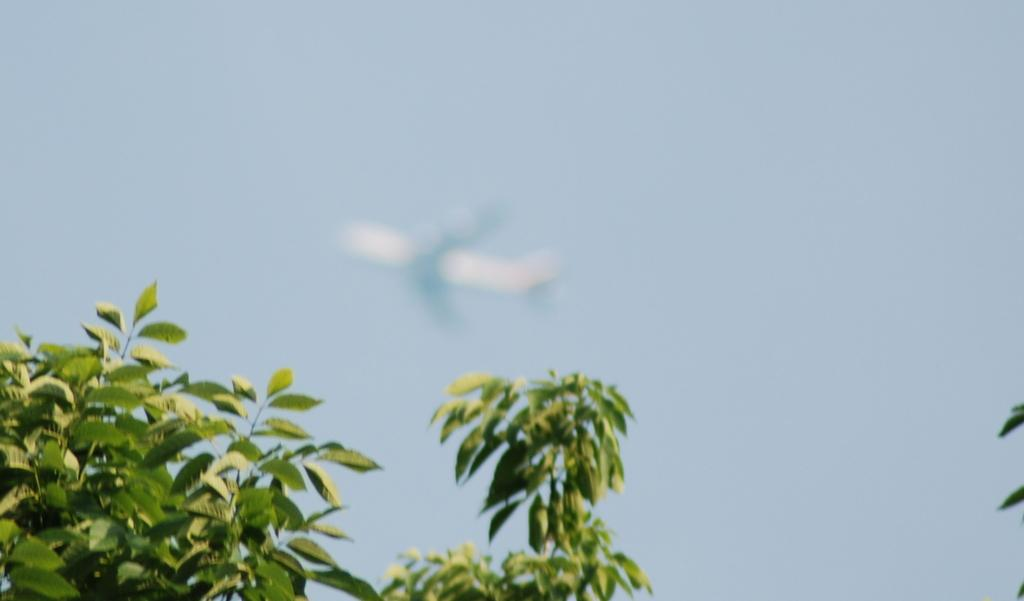What is the main subject of the image? The main subject of the image is an airplane. What is the airplane doing in the image? The airplane is flying in the sky. What type of natural scenery can be seen in the image? There are trees visible in the image. What type of activity is the swing performing in the image? There is no swing present in the image. 